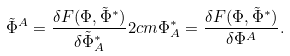Convert formula to latex. <formula><loc_0><loc_0><loc_500><loc_500>\tilde { \Phi } ^ { A } = \frac { \delta F ( \Phi , \tilde { \Phi } ^ { * } ) } { \delta \tilde { \Phi } _ { A } ^ { * } } 2 c m \Phi _ { A } ^ { * } = \frac { \delta F ( \Phi , \tilde { \Phi } ^ { * } ) } { \delta \Phi ^ { A } } .</formula> 